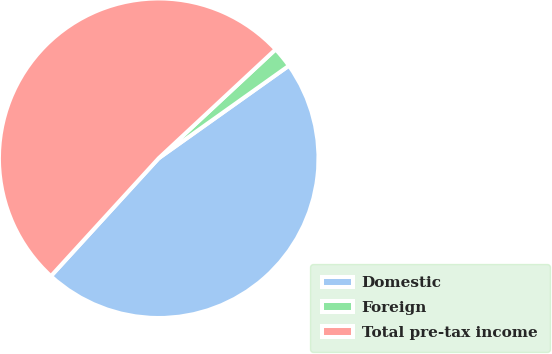Convert chart to OTSL. <chart><loc_0><loc_0><loc_500><loc_500><pie_chart><fcel>Domestic<fcel>Foreign<fcel>Total pre-tax income<nl><fcel>46.62%<fcel>2.1%<fcel>51.28%<nl></chart> 